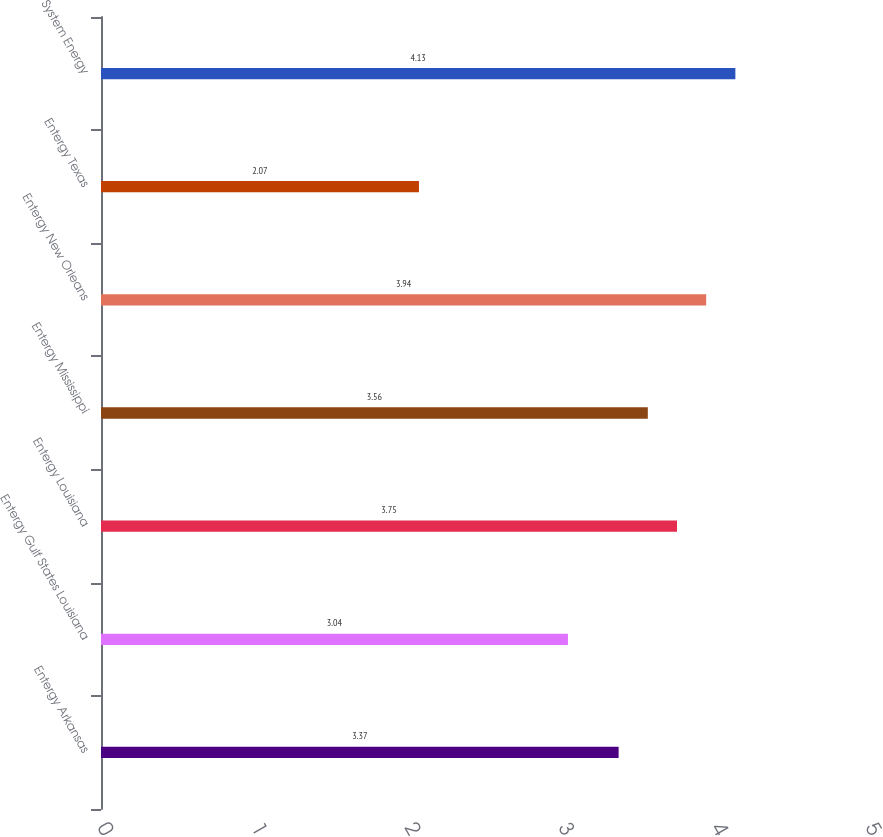<chart> <loc_0><loc_0><loc_500><loc_500><bar_chart><fcel>Entergy Arkansas<fcel>Entergy Gulf States Louisiana<fcel>Entergy Louisiana<fcel>Entergy Mississippi<fcel>Entergy New Orleans<fcel>Entergy Texas<fcel>System Energy<nl><fcel>3.37<fcel>3.04<fcel>3.75<fcel>3.56<fcel>3.94<fcel>2.07<fcel>4.13<nl></chart> 